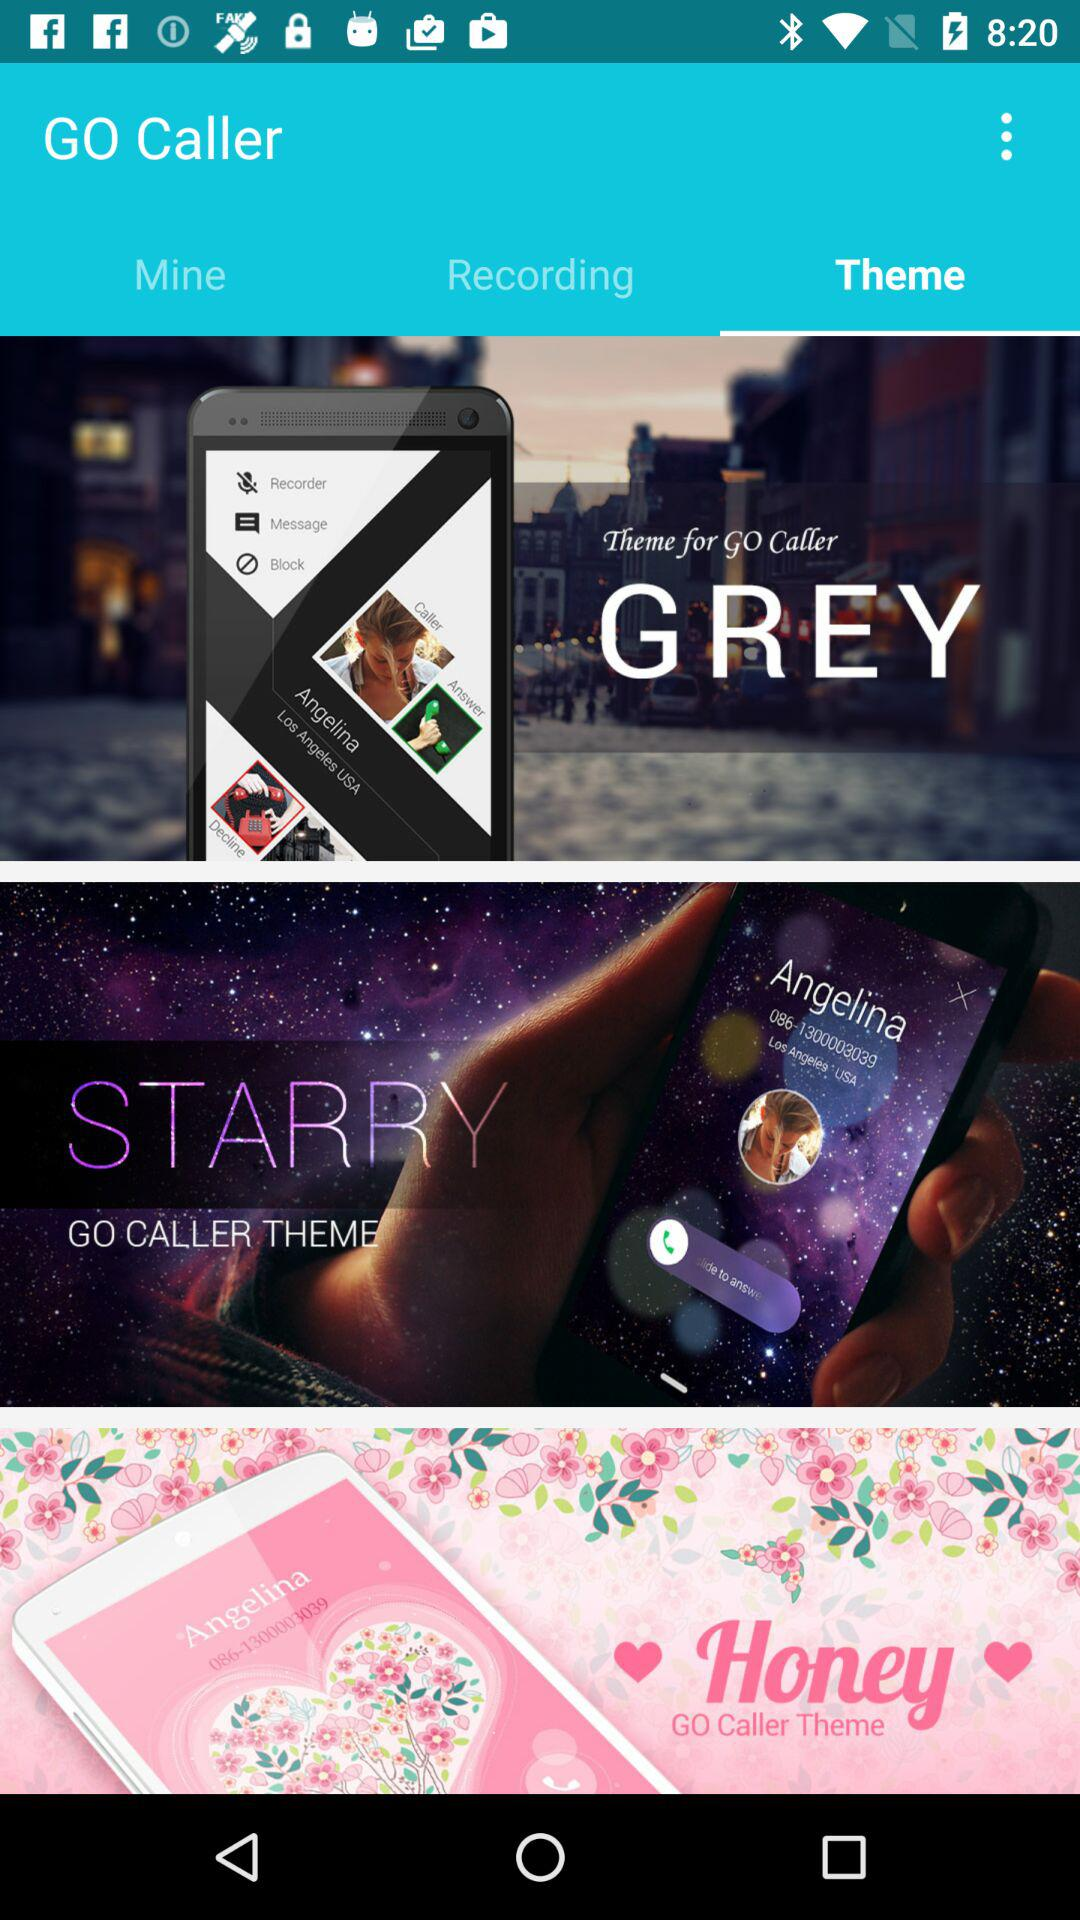How many themes are there?
Answer the question using a single word or phrase. 3 